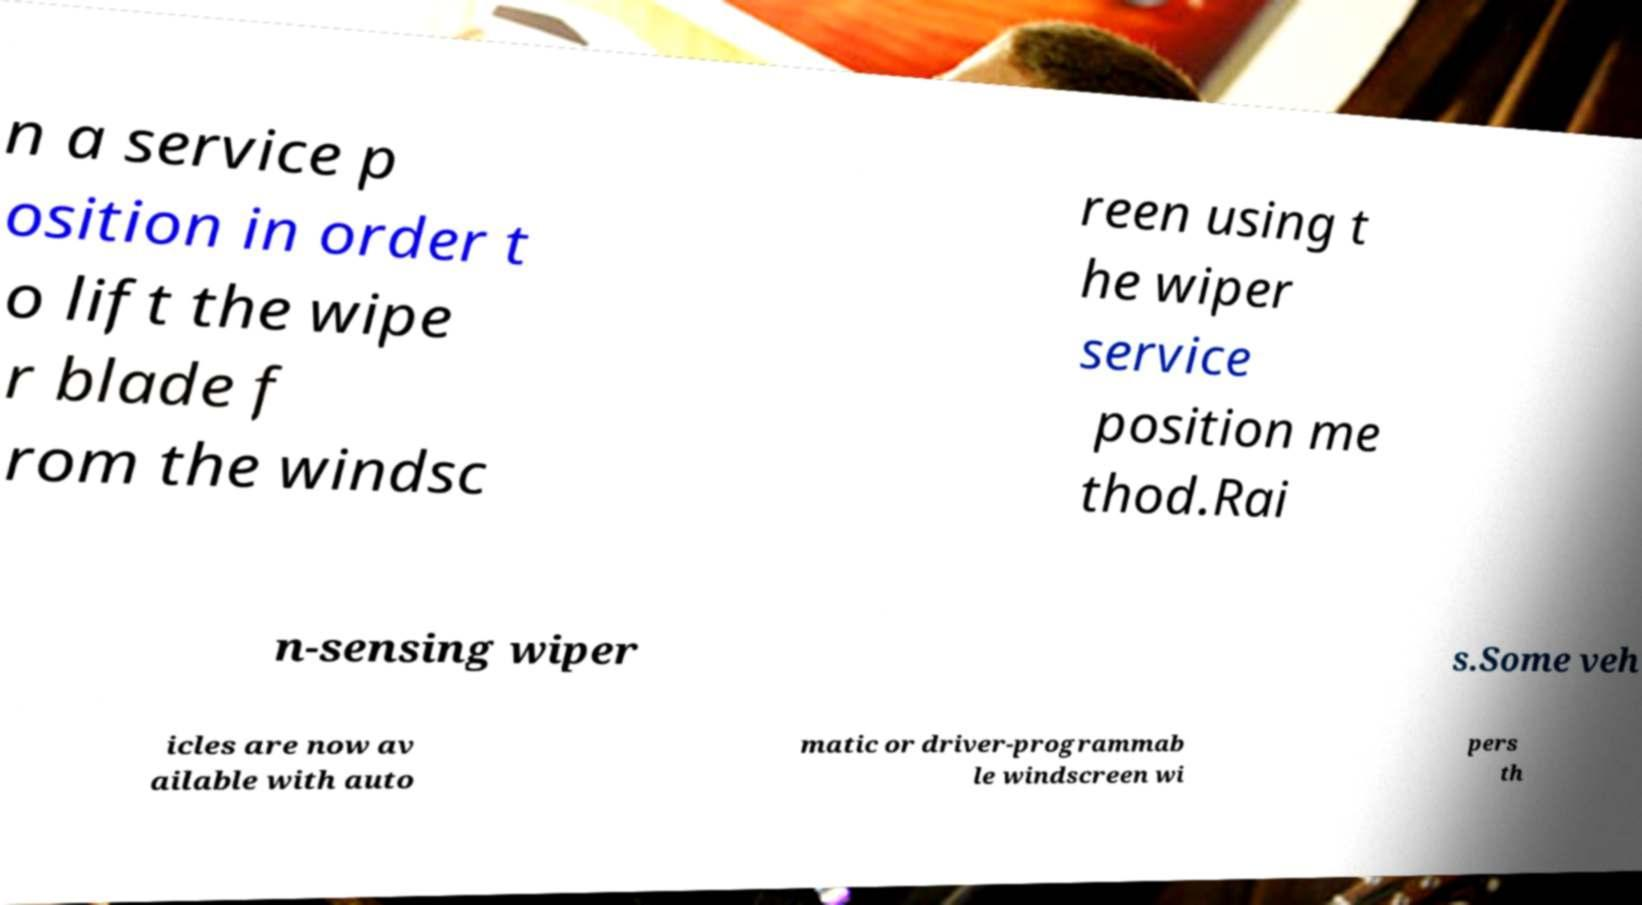Please identify and transcribe the text found in this image. n a service p osition in order t o lift the wipe r blade f rom the windsc reen using t he wiper service position me thod.Rai n-sensing wiper s.Some veh icles are now av ailable with auto matic or driver-programmab le windscreen wi pers th 